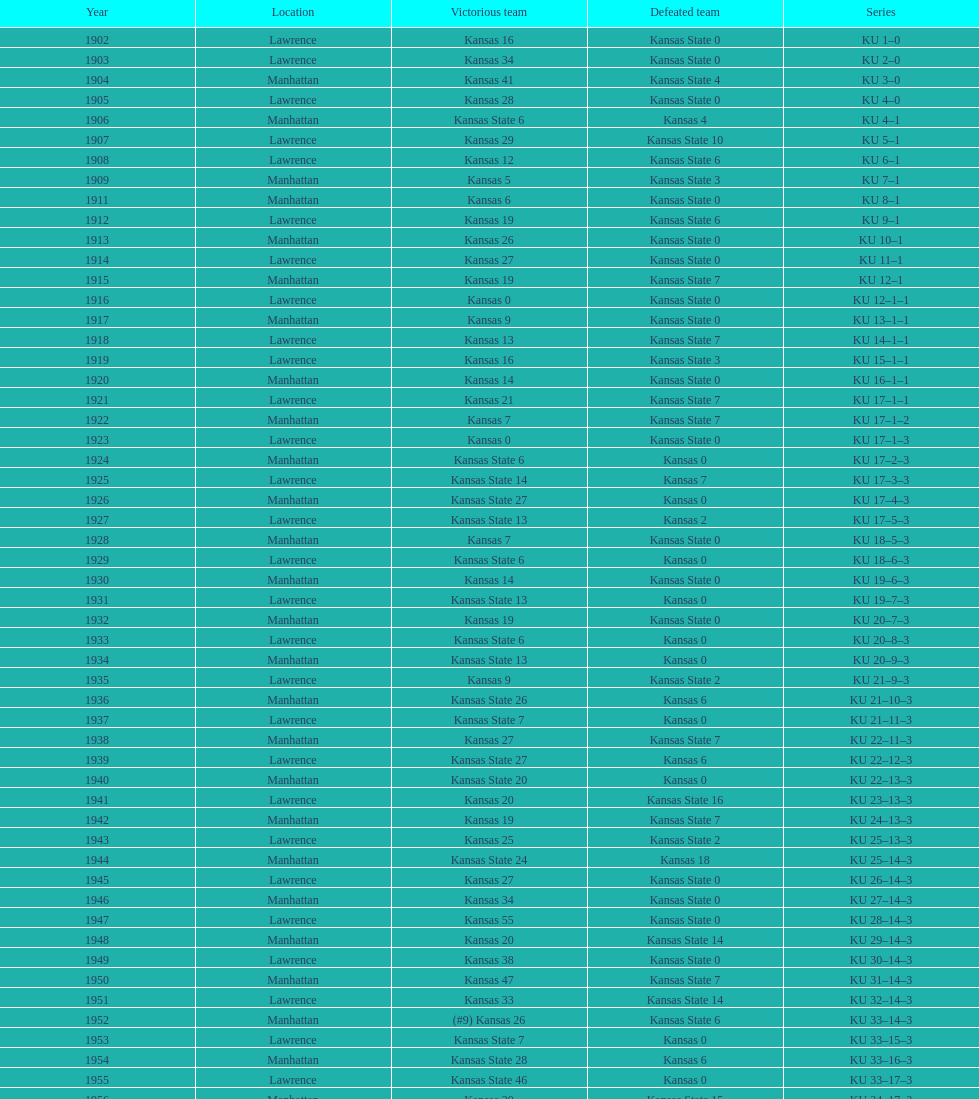Help me parse the entirety of this table. {'header': ['Year', 'Location', 'Victorious team', 'Defeated team', 'Series'], 'rows': [['1902', 'Lawrence', 'Kansas 16', 'Kansas State 0', 'KU 1–0'], ['1903', 'Lawrence', 'Kansas 34', 'Kansas State 0', 'KU 2–0'], ['1904', 'Manhattan', 'Kansas 41', 'Kansas State 4', 'KU 3–0'], ['1905', 'Lawrence', 'Kansas 28', 'Kansas State 0', 'KU 4–0'], ['1906', 'Manhattan', 'Kansas State 6', 'Kansas 4', 'KU 4–1'], ['1907', 'Lawrence', 'Kansas 29', 'Kansas State 10', 'KU 5–1'], ['1908', 'Lawrence', 'Kansas 12', 'Kansas State 6', 'KU 6–1'], ['1909', 'Manhattan', 'Kansas 5', 'Kansas State 3', 'KU 7–1'], ['1911', 'Manhattan', 'Kansas 6', 'Kansas State 0', 'KU 8–1'], ['1912', 'Lawrence', 'Kansas 19', 'Kansas State 6', 'KU 9–1'], ['1913', 'Manhattan', 'Kansas 26', 'Kansas State 0', 'KU 10–1'], ['1914', 'Lawrence', 'Kansas 27', 'Kansas State 0', 'KU 11–1'], ['1915', 'Manhattan', 'Kansas 19', 'Kansas State 7', 'KU 12–1'], ['1916', 'Lawrence', 'Kansas 0', 'Kansas State 0', 'KU 12–1–1'], ['1917', 'Manhattan', 'Kansas 9', 'Kansas State 0', 'KU 13–1–1'], ['1918', 'Lawrence', 'Kansas 13', 'Kansas State 7', 'KU 14–1–1'], ['1919', 'Lawrence', 'Kansas 16', 'Kansas State 3', 'KU 15–1–1'], ['1920', 'Manhattan', 'Kansas 14', 'Kansas State 0', 'KU 16–1–1'], ['1921', 'Lawrence', 'Kansas 21', 'Kansas State 7', 'KU 17–1–1'], ['1922', 'Manhattan', 'Kansas 7', 'Kansas State 7', 'KU 17–1–2'], ['1923', 'Lawrence', 'Kansas 0', 'Kansas State 0', 'KU 17–1–3'], ['1924', 'Manhattan', 'Kansas State 6', 'Kansas 0', 'KU 17–2–3'], ['1925', 'Lawrence', 'Kansas State 14', 'Kansas 7', 'KU 17–3–3'], ['1926', 'Manhattan', 'Kansas State 27', 'Kansas 0', 'KU 17–4–3'], ['1927', 'Lawrence', 'Kansas State 13', 'Kansas 2', 'KU 17–5–3'], ['1928', 'Manhattan', 'Kansas 7', 'Kansas State 0', 'KU 18–5–3'], ['1929', 'Lawrence', 'Kansas State 6', 'Kansas 0', 'KU 18–6–3'], ['1930', 'Manhattan', 'Kansas 14', 'Kansas State 0', 'KU 19–6–3'], ['1931', 'Lawrence', 'Kansas State 13', 'Kansas 0', 'KU 19–7–3'], ['1932', 'Manhattan', 'Kansas 19', 'Kansas State 0', 'KU 20–7–3'], ['1933', 'Lawrence', 'Kansas State 6', 'Kansas 0', 'KU 20–8–3'], ['1934', 'Manhattan', 'Kansas State 13', 'Kansas 0', 'KU 20–9–3'], ['1935', 'Lawrence', 'Kansas 9', 'Kansas State 2', 'KU 21–9–3'], ['1936', 'Manhattan', 'Kansas State 26', 'Kansas 6', 'KU 21–10–3'], ['1937', 'Lawrence', 'Kansas State 7', 'Kansas 0', 'KU 21–11–3'], ['1938', 'Manhattan', 'Kansas 27', 'Kansas State 7', 'KU 22–11–3'], ['1939', 'Lawrence', 'Kansas State 27', 'Kansas 6', 'KU 22–12–3'], ['1940', 'Manhattan', 'Kansas State 20', 'Kansas 0', 'KU 22–13–3'], ['1941', 'Lawrence', 'Kansas 20', 'Kansas State 16', 'KU 23–13–3'], ['1942', 'Manhattan', 'Kansas 19', 'Kansas State 7', 'KU 24–13–3'], ['1943', 'Lawrence', 'Kansas 25', 'Kansas State 2', 'KU 25–13–3'], ['1944', 'Manhattan', 'Kansas State 24', 'Kansas 18', 'KU 25–14–3'], ['1945', 'Lawrence', 'Kansas 27', 'Kansas State 0', 'KU 26–14–3'], ['1946', 'Manhattan', 'Kansas 34', 'Kansas State 0', 'KU 27–14–3'], ['1947', 'Lawrence', 'Kansas 55', 'Kansas State 0', 'KU 28–14–3'], ['1948', 'Manhattan', 'Kansas 20', 'Kansas State 14', 'KU 29–14–3'], ['1949', 'Lawrence', 'Kansas 38', 'Kansas State 0', 'KU 30–14–3'], ['1950', 'Manhattan', 'Kansas 47', 'Kansas State 7', 'KU 31–14–3'], ['1951', 'Lawrence', 'Kansas 33', 'Kansas State 14', 'KU 32–14–3'], ['1952', 'Manhattan', '(#9) Kansas 26', 'Kansas State 6', 'KU 33–14–3'], ['1953', 'Lawrence', 'Kansas State 7', 'Kansas 0', 'KU 33–15–3'], ['1954', 'Manhattan', 'Kansas State 28', 'Kansas 6', 'KU 33–16–3'], ['1955', 'Lawrence', 'Kansas State 46', 'Kansas 0', 'KU 33–17–3'], ['1956', 'Manhattan', 'Kansas 20', 'Kansas State 15', 'KU 34–17–3'], ['1957', 'Lawrence', 'Kansas 13', 'Kansas State 7', 'KU 35–17–3'], ['1958', 'Manhattan', 'Kansas 21', 'Kansas State 12', 'KU 36–17–3'], ['1959', 'Lawrence', 'Kansas 33', 'Kansas State 14', 'KU 37–17–3'], ['1960', 'Manhattan', 'Kansas 41', 'Kansas State 0', 'KU 38–17–3'], ['1961', 'Lawrence', 'Kansas 34', 'Kansas State 0', 'KU 39–17–3'], ['1962', 'Manhattan', 'Kansas 38', 'Kansas State 0', 'KU 40–17–3'], ['1963', 'Lawrence', 'Kansas 34', 'Kansas State 0', 'KU 41–17–3'], ['1964', 'Manhattan', 'Kansas 7', 'Kansas State 0', 'KU 42–17–3'], ['1965', 'Lawrence', 'Kansas 34', 'Kansas State 0', 'KU 43–17–3'], ['1966', 'Manhattan', 'Kansas 3', 'Kansas State 3', 'KU 43–17–4'], ['1967', 'Lawrence', 'Kansas 17', 'Kansas State 16', 'KU 44–17–4'], ['1968', 'Manhattan', '(#7) Kansas 38', 'Kansas State 29', 'KU 45–17–4']]} Who had the most wins in the 1950's: kansas or kansas state? Kansas. 